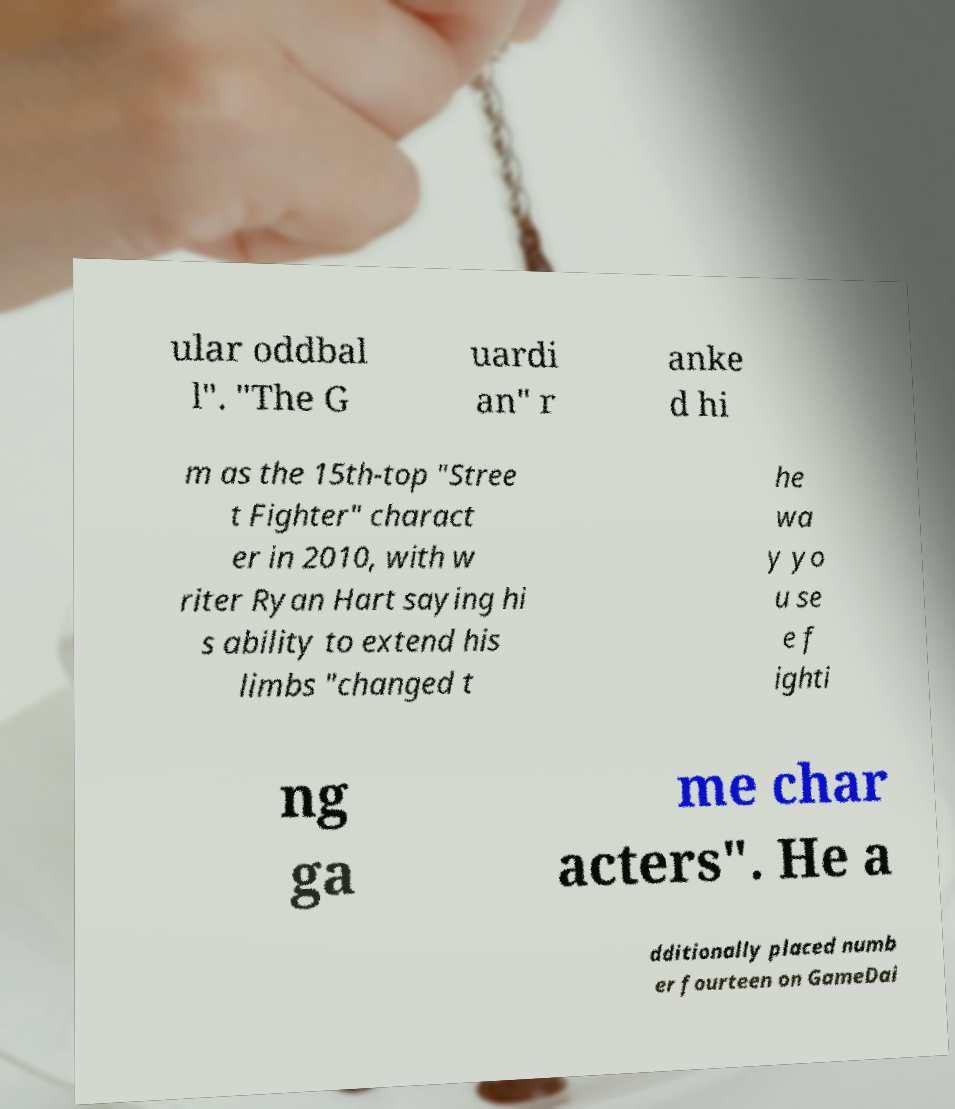What messages or text are displayed in this image? I need them in a readable, typed format. ular oddbal l". "The G uardi an" r anke d hi m as the 15th-top "Stree t Fighter" charact er in 2010, with w riter Ryan Hart saying hi s ability to extend his limbs "changed t he wa y yo u se e f ighti ng ga me char acters". He a dditionally placed numb er fourteen on GameDai 